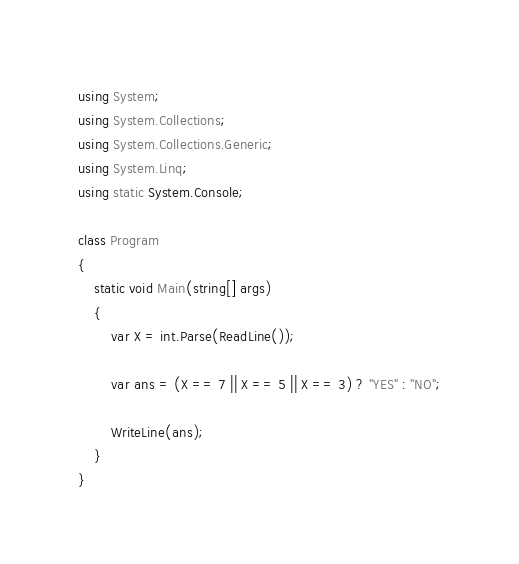Convert code to text. <code><loc_0><loc_0><loc_500><loc_500><_C#_>using System;
using System.Collections;
using System.Collections.Generic;
using System.Linq;
using static System.Console;

class Program
{
    static void Main(string[] args)
    {
        var X = int.Parse(ReadLine());

        var ans = (X == 7 || X == 5 || X == 3) ? "YES" : "NO";

        WriteLine(ans);
    }
}
</code> 